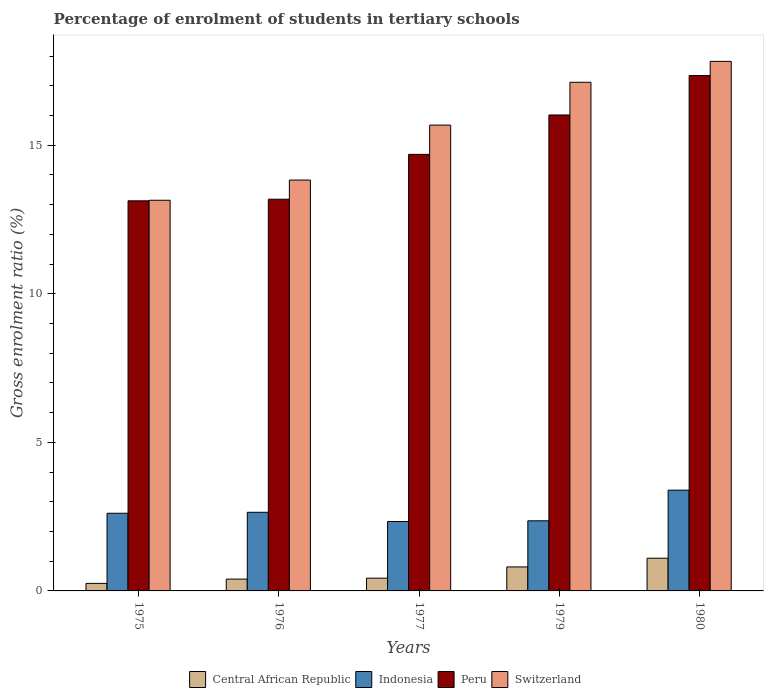Are the number of bars per tick equal to the number of legend labels?
Keep it short and to the point. Yes. What is the label of the 5th group of bars from the left?
Offer a very short reply. 1980. What is the percentage of students enrolled in tertiary schools in Peru in 1975?
Ensure brevity in your answer.  13.13. Across all years, what is the maximum percentage of students enrolled in tertiary schools in Central African Republic?
Offer a terse response. 1.1. Across all years, what is the minimum percentage of students enrolled in tertiary schools in Peru?
Keep it short and to the point. 13.13. In which year was the percentage of students enrolled in tertiary schools in Peru minimum?
Offer a very short reply. 1975. What is the total percentage of students enrolled in tertiary schools in Peru in the graph?
Your answer should be compact. 74.37. What is the difference between the percentage of students enrolled in tertiary schools in Switzerland in 1975 and that in 1976?
Provide a short and direct response. -0.68. What is the difference between the percentage of students enrolled in tertiary schools in Central African Republic in 1975 and the percentage of students enrolled in tertiary schools in Peru in 1980?
Provide a short and direct response. -17.09. What is the average percentage of students enrolled in tertiary schools in Central African Republic per year?
Your answer should be compact. 0.6. In the year 1976, what is the difference between the percentage of students enrolled in tertiary schools in Indonesia and percentage of students enrolled in tertiary schools in Switzerland?
Ensure brevity in your answer.  -11.18. In how many years, is the percentage of students enrolled in tertiary schools in Central African Republic greater than 5 %?
Provide a succinct answer. 0. What is the ratio of the percentage of students enrolled in tertiary schools in Central African Republic in 1975 to that in 1980?
Offer a terse response. 0.23. What is the difference between the highest and the second highest percentage of students enrolled in tertiary schools in Switzerland?
Your response must be concise. 0.7. What is the difference between the highest and the lowest percentage of students enrolled in tertiary schools in Peru?
Provide a short and direct response. 4.22. In how many years, is the percentage of students enrolled in tertiary schools in Switzerland greater than the average percentage of students enrolled in tertiary schools in Switzerland taken over all years?
Offer a terse response. 3. Is the sum of the percentage of students enrolled in tertiary schools in Indonesia in 1975 and 1977 greater than the maximum percentage of students enrolled in tertiary schools in Central African Republic across all years?
Provide a short and direct response. Yes. Is it the case that in every year, the sum of the percentage of students enrolled in tertiary schools in Switzerland and percentage of students enrolled in tertiary schools in Central African Republic is greater than the sum of percentage of students enrolled in tertiary schools in Indonesia and percentage of students enrolled in tertiary schools in Peru?
Offer a very short reply. No. What does the 1st bar from the right in 1977 represents?
Your answer should be compact. Switzerland. How many bars are there?
Your answer should be very brief. 20. Are all the bars in the graph horizontal?
Your answer should be compact. No. How many years are there in the graph?
Keep it short and to the point. 5. Are the values on the major ticks of Y-axis written in scientific E-notation?
Provide a succinct answer. No. Does the graph contain any zero values?
Provide a succinct answer. No. How are the legend labels stacked?
Offer a terse response. Horizontal. What is the title of the graph?
Provide a short and direct response. Percentage of enrolment of students in tertiary schools. Does "Haiti" appear as one of the legend labels in the graph?
Offer a very short reply. No. What is the label or title of the Y-axis?
Offer a terse response. Gross enrolment ratio (%). What is the Gross enrolment ratio (%) of Central African Republic in 1975?
Offer a very short reply. 0.25. What is the Gross enrolment ratio (%) in Indonesia in 1975?
Your answer should be compact. 2.61. What is the Gross enrolment ratio (%) in Peru in 1975?
Make the answer very short. 13.13. What is the Gross enrolment ratio (%) in Switzerland in 1975?
Offer a very short reply. 13.15. What is the Gross enrolment ratio (%) of Central African Republic in 1976?
Your answer should be very brief. 0.4. What is the Gross enrolment ratio (%) of Indonesia in 1976?
Offer a terse response. 2.65. What is the Gross enrolment ratio (%) in Peru in 1976?
Provide a short and direct response. 13.18. What is the Gross enrolment ratio (%) of Switzerland in 1976?
Your answer should be compact. 13.83. What is the Gross enrolment ratio (%) of Central African Republic in 1977?
Keep it short and to the point. 0.43. What is the Gross enrolment ratio (%) in Indonesia in 1977?
Keep it short and to the point. 2.34. What is the Gross enrolment ratio (%) of Peru in 1977?
Your response must be concise. 14.69. What is the Gross enrolment ratio (%) of Switzerland in 1977?
Your answer should be very brief. 15.68. What is the Gross enrolment ratio (%) in Central African Republic in 1979?
Provide a succinct answer. 0.81. What is the Gross enrolment ratio (%) of Indonesia in 1979?
Keep it short and to the point. 2.36. What is the Gross enrolment ratio (%) in Peru in 1979?
Your answer should be very brief. 16.02. What is the Gross enrolment ratio (%) of Switzerland in 1979?
Make the answer very short. 17.12. What is the Gross enrolment ratio (%) of Central African Republic in 1980?
Offer a very short reply. 1.1. What is the Gross enrolment ratio (%) of Indonesia in 1980?
Your response must be concise. 3.39. What is the Gross enrolment ratio (%) in Peru in 1980?
Give a very brief answer. 17.35. What is the Gross enrolment ratio (%) in Switzerland in 1980?
Provide a succinct answer. 17.82. Across all years, what is the maximum Gross enrolment ratio (%) in Central African Republic?
Ensure brevity in your answer.  1.1. Across all years, what is the maximum Gross enrolment ratio (%) in Indonesia?
Provide a succinct answer. 3.39. Across all years, what is the maximum Gross enrolment ratio (%) of Peru?
Offer a terse response. 17.35. Across all years, what is the maximum Gross enrolment ratio (%) in Switzerland?
Make the answer very short. 17.82. Across all years, what is the minimum Gross enrolment ratio (%) in Central African Republic?
Your answer should be compact. 0.25. Across all years, what is the minimum Gross enrolment ratio (%) in Indonesia?
Provide a succinct answer. 2.34. Across all years, what is the minimum Gross enrolment ratio (%) in Peru?
Your response must be concise. 13.13. Across all years, what is the minimum Gross enrolment ratio (%) of Switzerland?
Offer a terse response. 13.15. What is the total Gross enrolment ratio (%) in Central African Republic in the graph?
Give a very brief answer. 2.99. What is the total Gross enrolment ratio (%) in Indonesia in the graph?
Offer a very short reply. 13.35. What is the total Gross enrolment ratio (%) in Peru in the graph?
Ensure brevity in your answer.  74.37. What is the total Gross enrolment ratio (%) in Switzerland in the graph?
Provide a succinct answer. 77.6. What is the difference between the Gross enrolment ratio (%) in Central African Republic in 1975 and that in 1976?
Ensure brevity in your answer.  -0.14. What is the difference between the Gross enrolment ratio (%) of Indonesia in 1975 and that in 1976?
Keep it short and to the point. -0.03. What is the difference between the Gross enrolment ratio (%) in Peru in 1975 and that in 1976?
Offer a terse response. -0.05. What is the difference between the Gross enrolment ratio (%) of Switzerland in 1975 and that in 1976?
Your answer should be compact. -0.68. What is the difference between the Gross enrolment ratio (%) of Central African Republic in 1975 and that in 1977?
Your response must be concise. -0.18. What is the difference between the Gross enrolment ratio (%) of Indonesia in 1975 and that in 1977?
Offer a terse response. 0.28. What is the difference between the Gross enrolment ratio (%) of Peru in 1975 and that in 1977?
Provide a short and direct response. -1.56. What is the difference between the Gross enrolment ratio (%) in Switzerland in 1975 and that in 1977?
Make the answer very short. -2.53. What is the difference between the Gross enrolment ratio (%) of Central African Republic in 1975 and that in 1979?
Make the answer very short. -0.55. What is the difference between the Gross enrolment ratio (%) in Indonesia in 1975 and that in 1979?
Your answer should be very brief. 0.25. What is the difference between the Gross enrolment ratio (%) in Peru in 1975 and that in 1979?
Offer a terse response. -2.89. What is the difference between the Gross enrolment ratio (%) in Switzerland in 1975 and that in 1979?
Provide a succinct answer. -3.97. What is the difference between the Gross enrolment ratio (%) in Central African Republic in 1975 and that in 1980?
Offer a terse response. -0.85. What is the difference between the Gross enrolment ratio (%) in Indonesia in 1975 and that in 1980?
Ensure brevity in your answer.  -0.78. What is the difference between the Gross enrolment ratio (%) in Peru in 1975 and that in 1980?
Offer a very short reply. -4.22. What is the difference between the Gross enrolment ratio (%) in Switzerland in 1975 and that in 1980?
Offer a very short reply. -4.67. What is the difference between the Gross enrolment ratio (%) in Central African Republic in 1976 and that in 1977?
Your answer should be very brief. -0.03. What is the difference between the Gross enrolment ratio (%) of Indonesia in 1976 and that in 1977?
Your answer should be compact. 0.31. What is the difference between the Gross enrolment ratio (%) in Peru in 1976 and that in 1977?
Your answer should be compact. -1.51. What is the difference between the Gross enrolment ratio (%) in Switzerland in 1976 and that in 1977?
Your response must be concise. -1.85. What is the difference between the Gross enrolment ratio (%) of Central African Republic in 1976 and that in 1979?
Make the answer very short. -0.41. What is the difference between the Gross enrolment ratio (%) in Indonesia in 1976 and that in 1979?
Offer a terse response. 0.29. What is the difference between the Gross enrolment ratio (%) in Peru in 1976 and that in 1979?
Your answer should be compact. -2.84. What is the difference between the Gross enrolment ratio (%) in Switzerland in 1976 and that in 1979?
Provide a succinct answer. -3.29. What is the difference between the Gross enrolment ratio (%) in Central African Republic in 1976 and that in 1980?
Offer a terse response. -0.7. What is the difference between the Gross enrolment ratio (%) in Indonesia in 1976 and that in 1980?
Keep it short and to the point. -0.74. What is the difference between the Gross enrolment ratio (%) in Peru in 1976 and that in 1980?
Your answer should be compact. -4.16. What is the difference between the Gross enrolment ratio (%) of Switzerland in 1976 and that in 1980?
Provide a short and direct response. -3.99. What is the difference between the Gross enrolment ratio (%) of Central African Republic in 1977 and that in 1979?
Offer a very short reply. -0.38. What is the difference between the Gross enrolment ratio (%) in Indonesia in 1977 and that in 1979?
Provide a succinct answer. -0.02. What is the difference between the Gross enrolment ratio (%) in Peru in 1977 and that in 1979?
Provide a short and direct response. -1.33. What is the difference between the Gross enrolment ratio (%) of Switzerland in 1977 and that in 1979?
Your answer should be very brief. -1.44. What is the difference between the Gross enrolment ratio (%) of Central African Republic in 1977 and that in 1980?
Provide a short and direct response. -0.67. What is the difference between the Gross enrolment ratio (%) of Indonesia in 1977 and that in 1980?
Provide a succinct answer. -1.06. What is the difference between the Gross enrolment ratio (%) in Peru in 1977 and that in 1980?
Make the answer very short. -2.65. What is the difference between the Gross enrolment ratio (%) of Switzerland in 1977 and that in 1980?
Your answer should be compact. -2.15. What is the difference between the Gross enrolment ratio (%) in Central African Republic in 1979 and that in 1980?
Keep it short and to the point. -0.29. What is the difference between the Gross enrolment ratio (%) in Indonesia in 1979 and that in 1980?
Your answer should be very brief. -1.03. What is the difference between the Gross enrolment ratio (%) of Peru in 1979 and that in 1980?
Your response must be concise. -1.33. What is the difference between the Gross enrolment ratio (%) of Switzerland in 1979 and that in 1980?
Give a very brief answer. -0.7. What is the difference between the Gross enrolment ratio (%) in Central African Republic in 1975 and the Gross enrolment ratio (%) in Indonesia in 1976?
Your response must be concise. -2.39. What is the difference between the Gross enrolment ratio (%) of Central African Republic in 1975 and the Gross enrolment ratio (%) of Peru in 1976?
Make the answer very short. -12.93. What is the difference between the Gross enrolment ratio (%) in Central African Republic in 1975 and the Gross enrolment ratio (%) in Switzerland in 1976?
Your answer should be very brief. -13.57. What is the difference between the Gross enrolment ratio (%) of Indonesia in 1975 and the Gross enrolment ratio (%) of Peru in 1976?
Your response must be concise. -10.57. What is the difference between the Gross enrolment ratio (%) of Indonesia in 1975 and the Gross enrolment ratio (%) of Switzerland in 1976?
Offer a very short reply. -11.21. What is the difference between the Gross enrolment ratio (%) in Peru in 1975 and the Gross enrolment ratio (%) in Switzerland in 1976?
Your answer should be compact. -0.7. What is the difference between the Gross enrolment ratio (%) in Central African Republic in 1975 and the Gross enrolment ratio (%) in Indonesia in 1977?
Make the answer very short. -2.08. What is the difference between the Gross enrolment ratio (%) of Central African Republic in 1975 and the Gross enrolment ratio (%) of Peru in 1977?
Make the answer very short. -14.44. What is the difference between the Gross enrolment ratio (%) in Central African Republic in 1975 and the Gross enrolment ratio (%) in Switzerland in 1977?
Provide a succinct answer. -15.42. What is the difference between the Gross enrolment ratio (%) in Indonesia in 1975 and the Gross enrolment ratio (%) in Peru in 1977?
Provide a short and direct response. -12.08. What is the difference between the Gross enrolment ratio (%) in Indonesia in 1975 and the Gross enrolment ratio (%) in Switzerland in 1977?
Give a very brief answer. -13.06. What is the difference between the Gross enrolment ratio (%) of Peru in 1975 and the Gross enrolment ratio (%) of Switzerland in 1977?
Provide a succinct answer. -2.55. What is the difference between the Gross enrolment ratio (%) in Central African Republic in 1975 and the Gross enrolment ratio (%) in Indonesia in 1979?
Give a very brief answer. -2.11. What is the difference between the Gross enrolment ratio (%) in Central African Republic in 1975 and the Gross enrolment ratio (%) in Peru in 1979?
Give a very brief answer. -15.76. What is the difference between the Gross enrolment ratio (%) in Central African Republic in 1975 and the Gross enrolment ratio (%) in Switzerland in 1979?
Offer a terse response. -16.87. What is the difference between the Gross enrolment ratio (%) of Indonesia in 1975 and the Gross enrolment ratio (%) of Peru in 1979?
Your response must be concise. -13.4. What is the difference between the Gross enrolment ratio (%) of Indonesia in 1975 and the Gross enrolment ratio (%) of Switzerland in 1979?
Ensure brevity in your answer.  -14.51. What is the difference between the Gross enrolment ratio (%) in Peru in 1975 and the Gross enrolment ratio (%) in Switzerland in 1979?
Your answer should be compact. -3.99. What is the difference between the Gross enrolment ratio (%) in Central African Republic in 1975 and the Gross enrolment ratio (%) in Indonesia in 1980?
Make the answer very short. -3.14. What is the difference between the Gross enrolment ratio (%) in Central African Republic in 1975 and the Gross enrolment ratio (%) in Peru in 1980?
Provide a succinct answer. -17.09. What is the difference between the Gross enrolment ratio (%) of Central African Republic in 1975 and the Gross enrolment ratio (%) of Switzerland in 1980?
Ensure brevity in your answer.  -17.57. What is the difference between the Gross enrolment ratio (%) of Indonesia in 1975 and the Gross enrolment ratio (%) of Peru in 1980?
Provide a short and direct response. -14.73. What is the difference between the Gross enrolment ratio (%) in Indonesia in 1975 and the Gross enrolment ratio (%) in Switzerland in 1980?
Your answer should be very brief. -15.21. What is the difference between the Gross enrolment ratio (%) of Peru in 1975 and the Gross enrolment ratio (%) of Switzerland in 1980?
Offer a terse response. -4.69. What is the difference between the Gross enrolment ratio (%) of Central African Republic in 1976 and the Gross enrolment ratio (%) of Indonesia in 1977?
Provide a short and direct response. -1.94. What is the difference between the Gross enrolment ratio (%) of Central African Republic in 1976 and the Gross enrolment ratio (%) of Peru in 1977?
Keep it short and to the point. -14.29. What is the difference between the Gross enrolment ratio (%) in Central African Republic in 1976 and the Gross enrolment ratio (%) in Switzerland in 1977?
Give a very brief answer. -15.28. What is the difference between the Gross enrolment ratio (%) in Indonesia in 1976 and the Gross enrolment ratio (%) in Peru in 1977?
Give a very brief answer. -12.05. What is the difference between the Gross enrolment ratio (%) of Indonesia in 1976 and the Gross enrolment ratio (%) of Switzerland in 1977?
Offer a very short reply. -13.03. What is the difference between the Gross enrolment ratio (%) in Peru in 1976 and the Gross enrolment ratio (%) in Switzerland in 1977?
Offer a terse response. -2.49. What is the difference between the Gross enrolment ratio (%) in Central African Republic in 1976 and the Gross enrolment ratio (%) in Indonesia in 1979?
Provide a short and direct response. -1.96. What is the difference between the Gross enrolment ratio (%) of Central African Republic in 1976 and the Gross enrolment ratio (%) of Peru in 1979?
Your answer should be compact. -15.62. What is the difference between the Gross enrolment ratio (%) of Central African Republic in 1976 and the Gross enrolment ratio (%) of Switzerland in 1979?
Offer a terse response. -16.72. What is the difference between the Gross enrolment ratio (%) in Indonesia in 1976 and the Gross enrolment ratio (%) in Peru in 1979?
Offer a terse response. -13.37. What is the difference between the Gross enrolment ratio (%) in Indonesia in 1976 and the Gross enrolment ratio (%) in Switzerland in 1979?
Keep it short and to the point. -14.47. What is the difference between the Gross enrolment ratio (%) of Peru in 1976 and the Gross enrolment ratio (%) of Switzerland in 1979?
Your answer should be very brief. -3.94. What is the difference between the Gross enrolment ratio (%) in Central African Republic in 1976 and the Gross enrolment ratio (%) in Indonesia in 1980?
Your response must be concise. -2.99. What is the difference between the Gross enrolment ratio (%) of Central African Republic in 1976 and the Gross enrolment ratio (%) of Peru in 1980?
Provide a short and direct response. -16.95. What is the difference between the Gross enrolment ratio (%) in Central African Republic in 1976 and the Gross enrolment ratio (%) in Switzerland in 1980?
Your response must be concise. -17.43. What is the difference between the Gross enrolment ratio (%) in Indonesia in 1976 and the Gross enrolment ratio (%) in Peru in 1980?
Provide a succinct answer. -14.7. What is the difference between the Gross enrolment ratio (%) of Indonesia in 1976 and the Gross enrolment ratio (%) of Switzerland in 1980?
Offer a very short reply. -15.18. What is the difference between the Gross enrolment ratio (%) in Peru in 1976 and the Gross enrolment ratio (%) in Switzerland in 1980?
Provide a short and direct response. -4.64. What is the difference between the Gross enrolment ratio (%) of Central African Republic in 1977 and the Gross enrolment ratio (%) of Indonesia in 1979?
Ensure brevity in your answer.  -1.93. What is the difference between the Gross enrolment ratio (%) in Central African Republic in 1977 and the Gross enrolment ratio (%) in Peru in 1979?
Make the answer very short. -15.59. What is the difference between the Gross enrolment ratio (%) in Central African Republic in 1977 and the Gross enrolment ratio (%) in Switzerland in 1979?
Your response must be concise. -16.69. What is the difference between the Gross enrolment ratio (%) of Indonesia in 1977 and the Gross enrolment ratio (%) of Peru in 1979?
Give a very brief answer. -13.68. What is the difference between the Gross enrolment ratio (%) in Indonesia in 1977 and the Gross enrolment ratio (%) in Switzerland in 1979?
Provide a succinct answer. -14.78. What is the difference between the Gross enrolment ratio (%) in Peru in 1977 and the Gross enrolment ratio (%) in Switzerland in 1979?
Provide a short and direct response. -2.43. What is the difference between the Gross enrolment ratio (%) in Central African Republic in 1977 and the Gross enrolment ratio (%) in Indonesia in 1980?
Keep it short and to the point. -2.96. What is the difference between the Gross enrolment ratio (%) in Central African Republic in 1977 and the Gross enrolment ratio (%) in Peru in 1980?
Ensure brevity in your answer.  -16.92. What is the difference between the Gross enrolment ratio (%) in Central African Republic in 1977 and the Gross enrolment ratio (%) in Switzerland in 1980?
Offer a terse response. -17.39. What is the difference between the Gross enrolment ratio (%) of Indonesia in 1977 and the Gross enrolment ratio (%) of Peru in 1980?
Provide a short and direct response. -15.01. What is the difference between the Gross enrolment ratio (%) in Indonesia in 1977 and the Gross enrolment ratio (%) in Switzerland in 1980?
Your answer should be very brief. -15.49. What is the difference between the Gross enrolment ratio (%) in Peru in 1977 and the Gross enrolment ratio (%) in Switzerland in 1980?
Give a very brief answer. -3.13. What is the difference between the Gross enrolment ratio (%) in Central African Republic in 1979 and the Gross enrolment ratio (%) in Indonesia in 1980?
Keep it short and to the point. -2.58. What is the difference between the Gross enrolment ratio (%) in Central African Republic in 1979 and the Gross enrolment ratio (%) in Peru in 1980?
Give a very brief answer. -16.54. What is the difference between the Gross enrolment ratio (%) in Central African Republic in 1979 and the Gross enrolment ratio (%) in Switzerland in 1980?
Keep it short and to the point. -17.02. What is the difference between the Gross enrolment ratio (%) of Indonesia in 1979 and the Gross enrolment ratio (%) of Peru in 1980?
Provide a short and direct response. -14.99. What is the difference between the Gross enrolment ratio (%) of Indonesia in 1979 and the Gross enrolment ratio (%) of Switzerland in 1980?
Your answer should be compact. -15.46. What is the difference between the Gross enrolment ratio (%) in Peru in 1979 and the Gross enrolment ratio (%) in Switzerland in 1980?
Offer a terse response. -1.8. What is the average Gross enrolment ratio (%) in Central African Republic per year?
Offer a very short reply. 0.6. What is the average Gross enrolment ratio (%) of Indonesia per year?
Your answer should be very brief. 2.67. What is the average Gross enrolment ratio (%) in Peru per year?
Offer a terse response. 14.87. What is the average Gross enrolment ratio (%) of Switzerland per year?
Provide a short and direct response. 15.52. In the year 1975, what is the difference between the Gross enrolment ratio (%) of Central African Republic and Gross enrolment ratio (%) of Indonesia?
Your response must be concise. -2.36. In the year 1975, what is the difference between the Gross enrolment ratio (%) of Central African Republic and Gross enrolment ratio (%) of Peru?
Offer a terse response. -12.88. In the year 1975, what is the difference between the Gross enrolment ratio (%) in Central African Republic and Gross enrolment ratio (%) in Switzerland?
Ensure brevity in your answer.  -12.89. In the year 1975, what is the difference between the Gross enrolment ratio (%) in Indonesia and Gross enrolment ratio (%) in Peru?
Offer a terse response. -10.52. In the year 1975, what is the difference between the Gross enrolment ratio (%) in Indonesia and Gross enrolment ratio (%) in Switzerland?
Your answer should be compact. -10.53. In the year 1975, what is the difference between the Gross enrolment ratio (%) of Peru and Gross enrolment ratio (%) of Switzerland?
Ensure brevity in your answer.  -0.02. In the year 1976, what is the difference between the Gross enrolment ratio (%) in Central African Republic and Gross enrolment ratio (%) in Indonesia?
Your answer should be very brief. -2.25. In the year 1976, what is the difference between the Gross enrolment ratio (%) in Central African Republic and Gross enrolment ratio (%) in Peru?
Offer a terse response. -12.79. In the year 1976, what is the difference between the Gross enrolment ratio (%) in Central African Republic and Gross enrolment ratio (%) in Switzerland?
Your answer should be compact. -13.43. In the year 1976, what is the difference between the Gross enrolment ratio (%) in Indonesia and Gross enrolment ratio (%) in Peru?
Your answer should be very brief. -10.54. In the year 1976, what is the difference between the Gross enrolment ratio (%) of Indonesia and Gross enrolment ratio (%) of Switzerland?
Provide a succinct answer. -11.18. In the year 1976, what is the difference between the Gross enrolment ratio (%) of Peru and Gross enrolment ratio (%) of Switzerland?
Give a very brief answer. -0.65. In the year 1977, what is the difference between the Gross enrolment ratio (%) of Central African Republic and Gross enrolment ratio (%) of Indonesia?
Keep it short and to the point. -1.91. In the year 1977, what is the difference between the Gross enrolment ratio (%) of Central African Republic and Gross enrolment ratio (%) of Peru?
Your response must be concise. -14.26. In the year 1977, what is the difference between the Gross enrolment ratio (%) in Central African Republic and Gross enrolment ratio (%) in Switzerland?
Offer a terse response. -15.25. In the year 1977, what is the difference between the Gross enrolment ratio (%) in Indonesia and Gross enrolment ratio (%) in Peru?
Your answer should be compact. -12.36. In the year 1977, what is the difference between the Gross enrolment ratio (%) of Indonesia and Gross enrolment ratio (%) of Switzerland?
Your answer should be compact. -13.34. In the year 1977, what is the difference between the Gross enrolment ratio (%) of Peru and Gross enrolment ratio (%) of Switzerland?
Make the answer very short. -0.99. In the year 1979, what is the difference between the Gross enrolment ratio (%) in Central African Republic and Gross enrolment ratio (%) in Indonesia?
Your response must be concise. -1.55. In the year 1979, what is the difference between the Gross enrolment ratio (%) of Central African Republic and Gross enrolment ratio (%) of Peru?
Your answer should be compact. -15.21. In the year 1979, what is the difference between the Gross enrolment ratio (%) in Central African Republic and Gross enrolment ratio (%) in Switzerland?
Make the answer very short. -16.31. In the year 1979, what is the difference between the Gross enrolment ratio (%) of Indonesia and Gross enrolment ratio (%) of Peru?
Ensure brevity in your answer.  -13.66. In the year 1979, what is the difference between the Gross enrolment ratio (%) in Indonesia and Gross enrolment ratio (%) in Switzerland?
Your answer should be compact. -14.76. In the year 1979, what is the difference between the Gross enrolment ratio (%) of Peru and Gross enrolment ratio (%) of Switzerland?
Provide a short and direct response. -1.1. In the year 1980, what is the difference between the Gross enrolment ratio (%) of Central African Republic and Gross enrolment ratio (%) of Indonesia?
Provide a succinct answer. -2.29. In the year 1980, what is the difference between the Gross enrolment ratio (%) in Central African Republic and Gross enrolment ratio (%) in Peru?
Your response must be concise. -16.24. In the year 1980, what is the difference between the Gross enrolment ratio (%) in Central African Republic and Gross enrolment ratio (%) in Switzerland?
Your answer should be very brief. -16.72. In the year 1980, what is the difference between the Gross enrolment ratio (%) of Indonesia and Gross enrolment ratio (%) of Peru?
Offer a very short reply. -13.95. In the year 1980, what is the difference between the Gross enrolment ratio (%) in Indonesia and Gross enrolment ratio (%) in Switzerland?
Ensure brevity in your answer.  -14.43. In the year 1980, what is the difference between the Gross enrolment ratio (%) in Peru and Gross enrolment ratio (%) in Switzerland?
Provide a short and direct response. -0.48. What is the ratio of the Gross enrolment ratio (%) of Central African Republic in 1975 to that in 1976?
Give a very brief answer. 0.64. What is the ratio of the Gross enrolment ratio (%) in Switzerland in 1975 to that in 1976?
Ensure brevity in your answer.  0.95. What is the ratio of the Gross enrolment ratio (%) of Central African Republic in 1975 to that in 1977?
Ensure brevity in your answer.  0.59. What is the ratio of the Gross enrolment ratio (%) of Indonesia in 1975 to that in 1977?
Provide a short and direct response. 1.12. What is the ratio of the Gross enrolment ratio (%) in Peru in 1975 to that in 1977?
Offer a very short reply. 0.89. What is the ratio of the Gross enrolment ratio (%) in Switzerland in 1975 to that in 1977?
Give a very brief answer. 0.84. What is the ratio of the Gross enrolment ratio (%) of Central African Republic in 1975 to that in 1979?
Provide a succinct answer. 0.31. What is the ratio of the Gross enrolment ratio (%) of Indonesia in 1975 to that in 1979?
Your answer should be very brief. 1.11. What is the ratio of the Gross enrolment ratio (%) of Peru in 1975 to that in 1979?
Offer a terse response. 0.82. What is the ratio of the Gross enrolment ratio (%) of Switzerland in 1975 to that in 1979?
Offer a terse response. 0.77. What is the ratio of the Gross enrolment ratio (%) in Central African Republic in 1975 to that in 1980?
Your answer should be very brief. 0.23. What is the ratio of the Gross enrolment ratio (%) in Indonesia in 1975 to that in 1980?
Ensure brevity in your answer.  0.77. What is the ratio of the Gross enrolment ratio (%) in Peru in 1975 to that in 1980?
Your response must be concise. 0.76. What is the ratio of the Gross enrolment ratio (%) of Switzerland in 1975 to that in 1980?
Your answer should be compact. 0.74. What is the ratio of the Gross enrolment ratio (%) of Central African Republic in 1976 to that in 1977?
Provide a succinct answer. 0.93. What is the ratio of the Gross enrolment ratio (%) in Indonesia in 1976 to that in 1977?
Give a very brief answer. 1.13. What is the ratio of the Gross enrolment ratio (%) in Peru in 1976 to that in 1977?
Offer a very short reply. 0.9. What is the ratio of the Gross enrolment ratio (%) in Switzerland in 1976 to that in 1977?
Offer a very short reply. 0.88. What is the ratio of the Gross enrolment ratio (%) of Central African Republic in 1976 to that in 1979?
Ensure brevity in your answer.  0.49. What is the ratio of the Gross enrolment ratio (%) in Indonesia in 1976 to that in 1979?
Your answer should be compact. 1.12. What is the ratio of the Gross enrolment ratio (%) of Peru in 1976 to that in 1979?
Provide a succinct answer. 0.82. What is the ratio of the Gross enrolment ratio (%) in Switzerland in 1976 to that in 1979?
Offer a terse response. 0.81. What is the ratio of the Gross enrolment ratio (%) of Central African Republic in 1976 to that in 1980?
Keep it short and to the point. 0.36. What is the ratio of the Gross enrolment ratio (%) in Indonesia in 1976 to that in 1980?
Offer a very short reply. 0.78. What is the ratio of the Gross enrolment ratio (%) in Peru in 1976 to that in 1980?
Provide a succinct answer. 0.76. What is the ratio of the Gross enrolment ratio (%) of Switzerland in 1976 to that in 1980?
Your answer should be very brief. 0.78. What is the ratio of the Gross enrolment ratio (%) of Central African Republic in 1977 to that in 1979?
Provide a succinct answer. 0.53. What is the ratio of the Gross enrolment ratio (%) in Indonesia in 1977 to that in 1979?
Provide a succinct answer. 0.99. What is the ratio of the Gross enrolment ratio (%) of Peru in 1977 to that in 1979?
Your answer should be compact. 0.92. What is the ratio of the Gross enrolment ratio (%) in Switzerland in 1977 to that in 1979?
Provide a short and direct response. 0.92. What is the ratio of the Gross enrolment ratio (%) of Central African Republic in 1977 to that in 1980?
Ensure brevity in your answer.  0.39. What is the ratio of the Gross enrolment ratio (%) in Indonesia in 1977 to that in 1980?
Ensure brevity in your answer.  0.69. What is the ratio of the Gross enrolment ratio (%) in Peru in 1977 to that in 1980?
Provide a succinct answer. 0.85. What is the ratio of the Gross enrolment ratio (%) in Switzerland in 1977 to that in 1980?
Provide a short and direct response. 0.88. What is the ratio of the Gross enrolment ratio (%) in Central African Republic in 1979 to that in 1980?
Give a very brief answer. 0.73. What is the ratio of the Gross enrolment ratio (%) of Indonesia in 1979 to that in 1980?
Your response must be concise. 0.7. What is the ratio of the Gross enrolment ratio (%) in Peru in 1979 to that in 1980?
Give a very brief answer. 0.92. What is the ratio of the Gross enrolment ratio (%) in Switzerland in 1979 to that in 1980?
Ensure brevity in your answer.  0.96. What is the difference between the highest and the second highest Gross enrolment ratio (%) in Central African Republic?
Your answer should be very brief. 0.29. What is the difference between the highest and the second highest Gross enrolment ratio (%) of Indonesia?
Offer a very short reply. 0.74. What is the difference between the highest and the second highest Gross enrolment ratio (%) in Peru?
Ensure brevity in your answer.  1.33. What is the difference between the highest and the second highest Gross enrolment ratio (%) in Switzerland?
Provide a short and direct response. 0.7. What is the difference between the highest and the lowest Gross enrolment ratio (%) in Central African Republic?
Ensure brevity in your answer.  0.85. What is the difference between the highest and the lowest Gross enrolment ratio (%) in Indonesia?
Your answer should be very brief. 1.06. What is the difference between the highest and the lowest Gross enrolment ratio (%) of Peru?
Offer a very short reply. 4.22. What is the difference between the highest and the lowest Gross enrolment ratio (%) of Switzerland?
Your response must be concise. 4.67. 